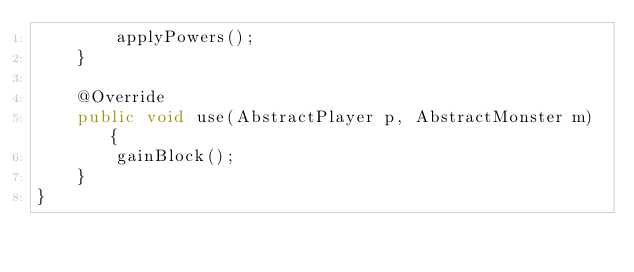Convert code to text. <code><loc_0><loc_0><loc_500><loc_500><_Java_>        applyPowers();
    }

    @Override
    public void use(AbstractPlayer p, AbstractMonster m) {
        gainBlock();
    }
}
</code> 